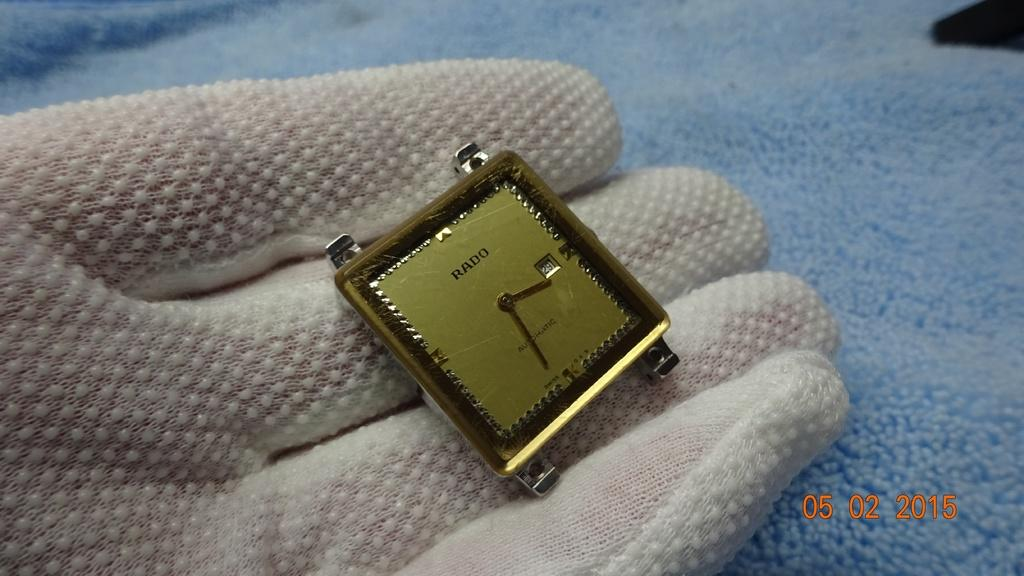<image>
Share a concise interpretation of the image provided. A gloved hand is holding just the face of a watch made by Rado. 